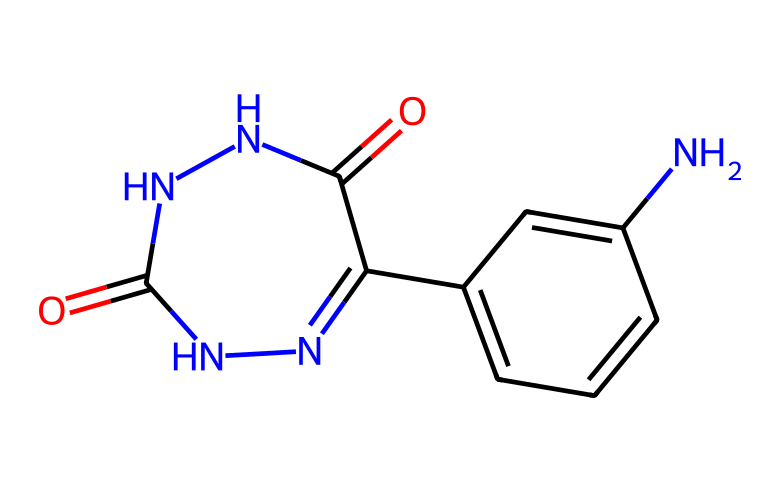How many nitrogen atoms are in luminol? By examining the SMILES representation, I count the number of 'N' characters. In the provided structure, there are four occurrences of 'N', indicating that there are four nitrogen atoms.
Answer: four What is the functional group present in luminol associated with its chemical properties? The structure includes carbonyl groups (C=O). These are present in the form of ketones or amides. Here, they are part of the compound's overall structure, lending to its reactivity and functionalities in detection.
Answer: carbonyl How many carbon atoms are in luminol? Counting the number of 'C' characters in the SMILES representation gives a total of nine carbon atoms in the structure of luminol.
Answer: nine What is the molecular formula of luminol? To derive the molecular formula, I would sum up the number of each type of atom identified: carbon (C), hydrogen (H), nitrogen (N), and oxygen (O). The structure shows 9 carbon, 8 hydrogen, 4 nitrogen, and 4 oxygen, leading to the formula C9H8N4O2.
Answer: C9H8N4O2 Is luminol a polar or non-polar compound? Analyzing the presence of polar groups (like the carbonyl and amine groups), I can confirm luminol is polar due to these functional groups, making it soluble in polar solvents, which is typical for compounds used in detection methods.
Answer: polar 